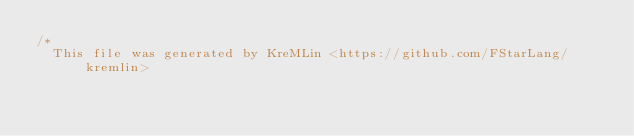Convert code to text. <code><loc_0><loc_0><loc_500><loc_500><_C_>/* 
  This file was generated by KreMLin <https://github.com/FStarLang/kremlin></code> 